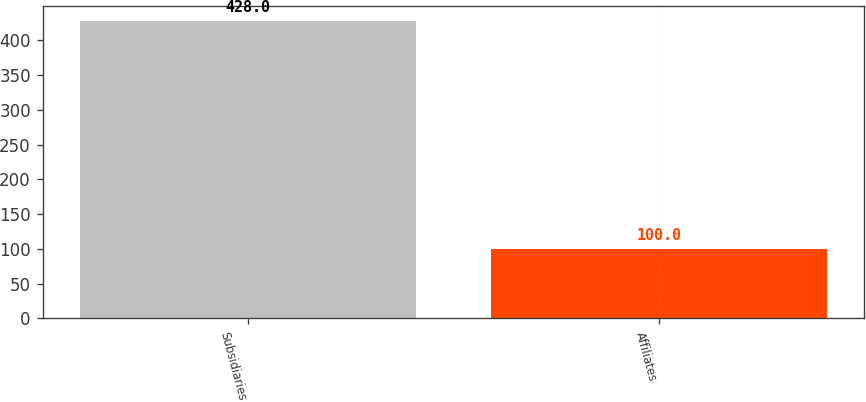<chart> <loc_0><loc_0><loc_500><loc_500><bar_chart><fcel>Subsidiaries<fcel>Affiliates<nl><fcel>428<fcel>100<nl></chart> 